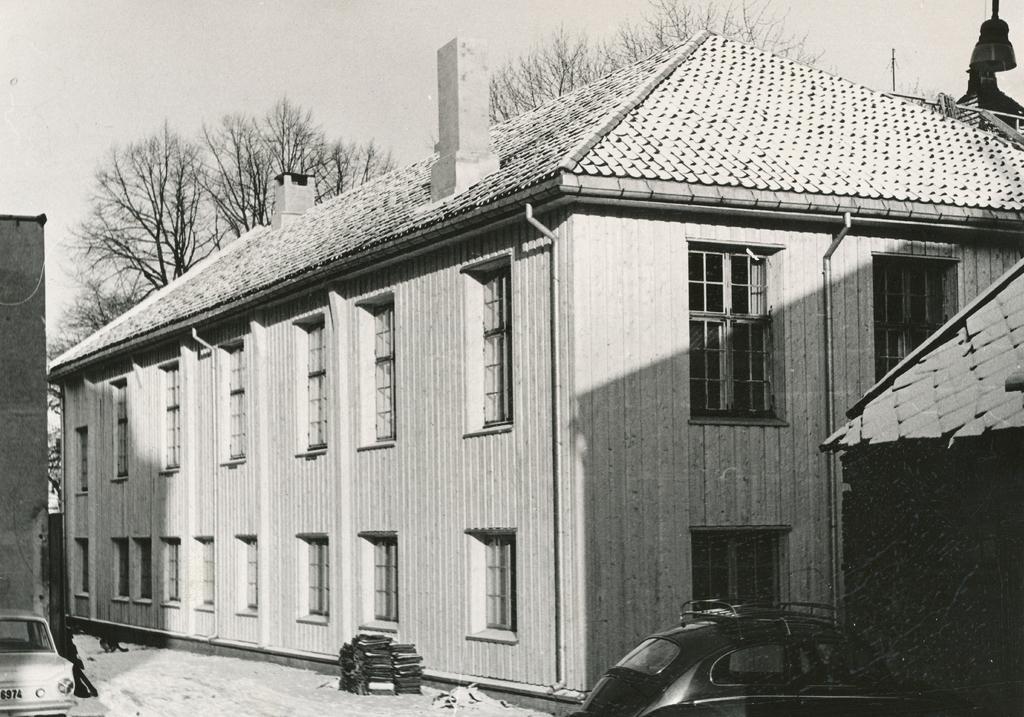Describe this image in one or two sentences. In this image we can see a building, pipelines, windows, trees, sky, street bulb, cars, snow and a chimney. 